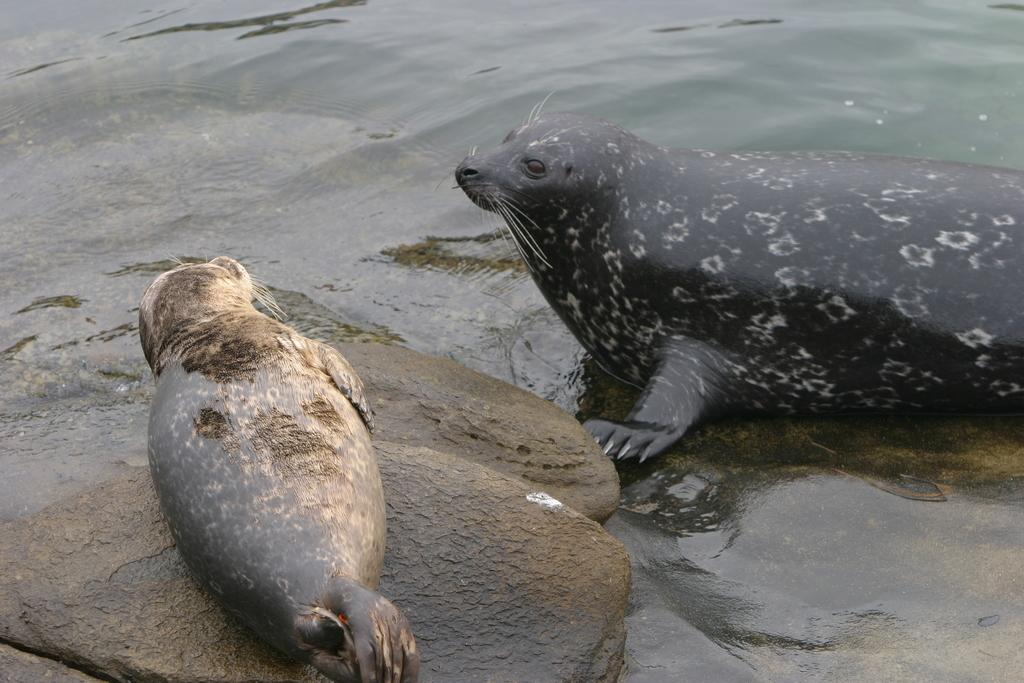What animals can be seen in the image? There are seals in the image. What type of terrain is visible at the bottom of the image? There are rocks at the bottom of the image. What natural element is visible in the background of the image? There is water visible in the background of the image. What type of earth can be seen in the image? There is no specific type of earth mentioned or visible in the image; it features seals, rocks, and water. 